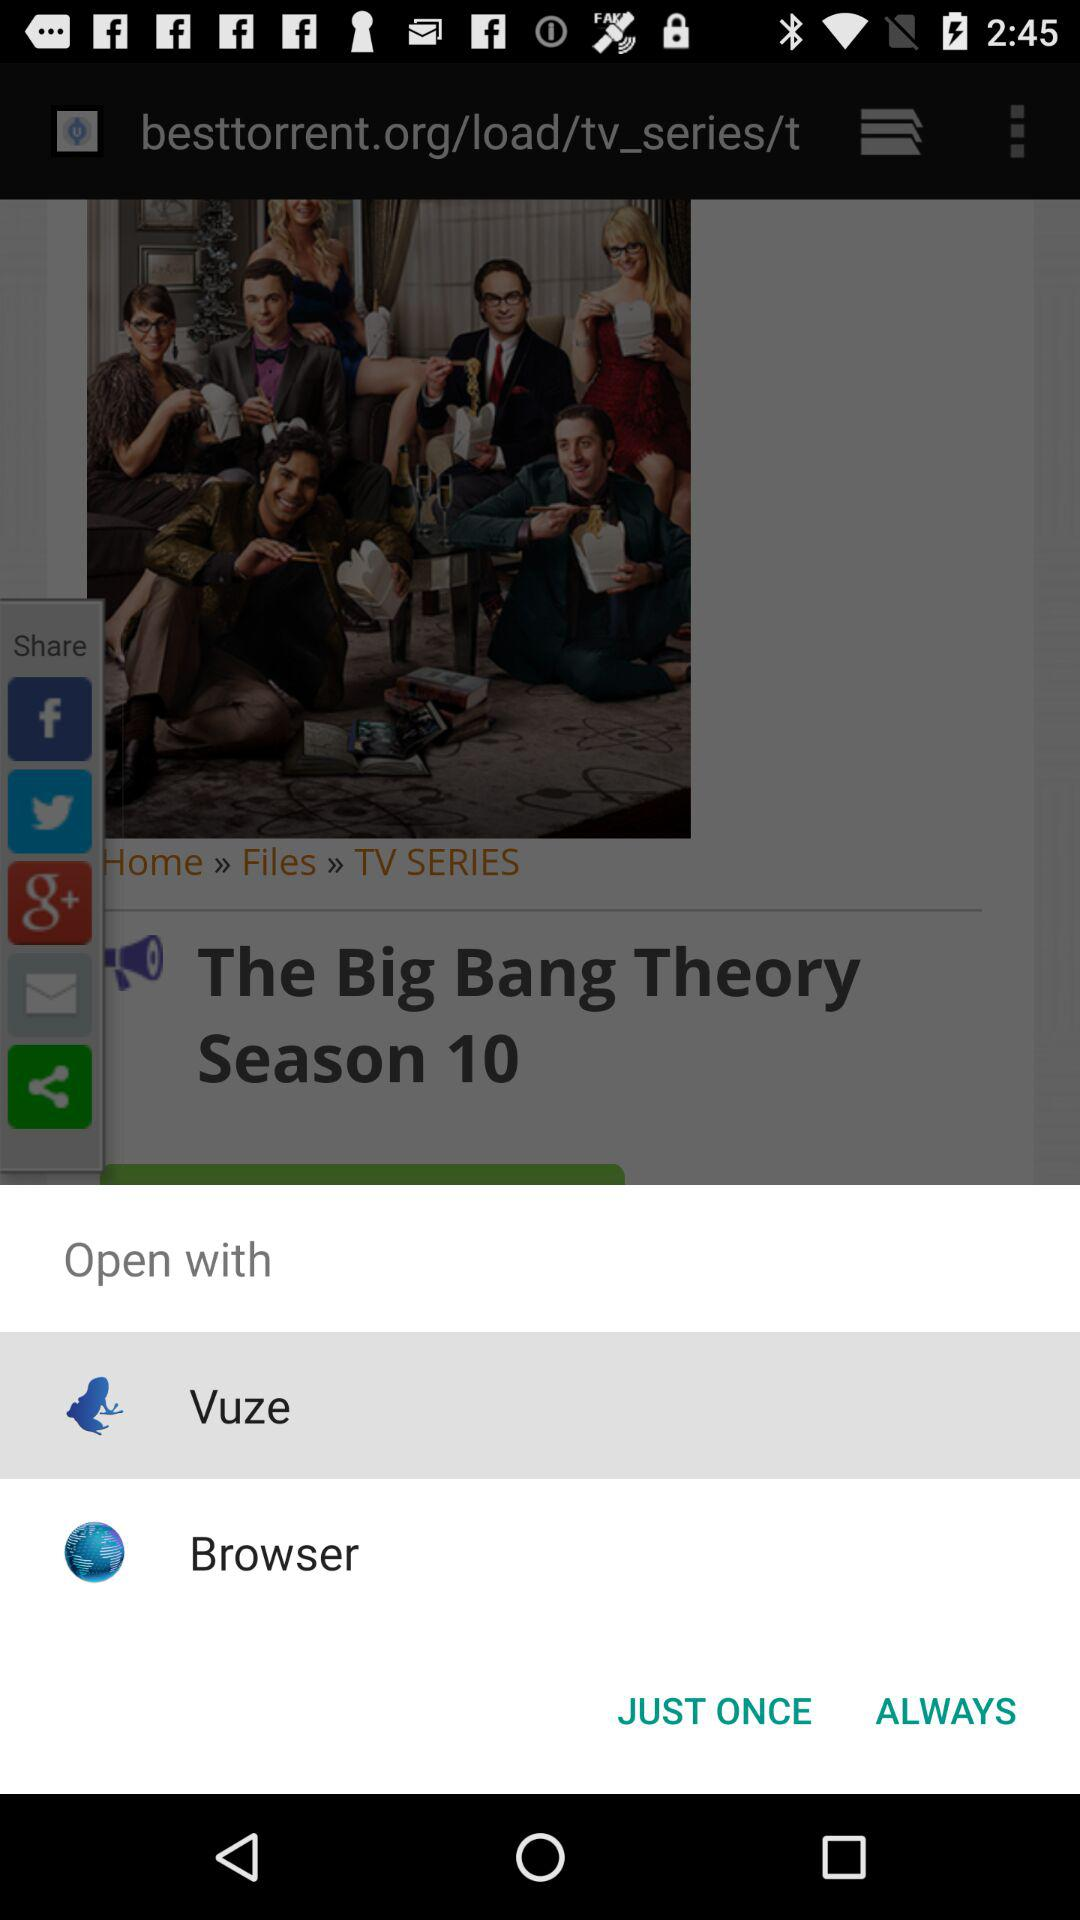Which application can be used to open it? The applications "Vuze" and "Browser" can be used to open it. 